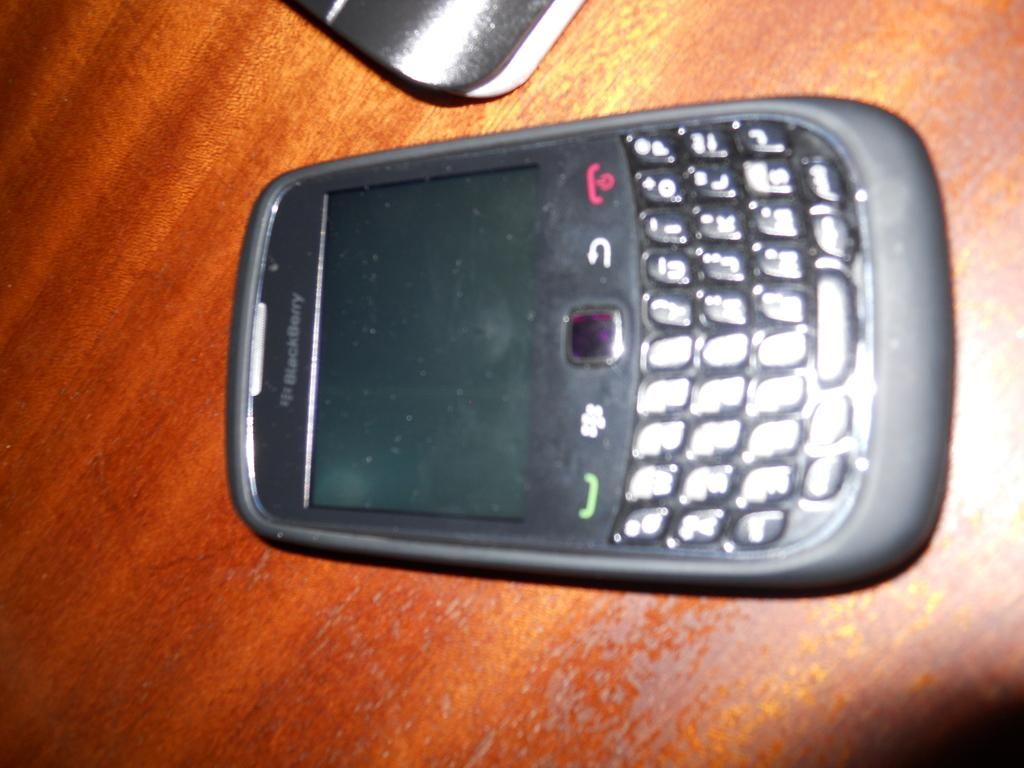<image>
Write a terse but informative summary of the picture. A Blackberry phone with a keyboard sits on a table. 